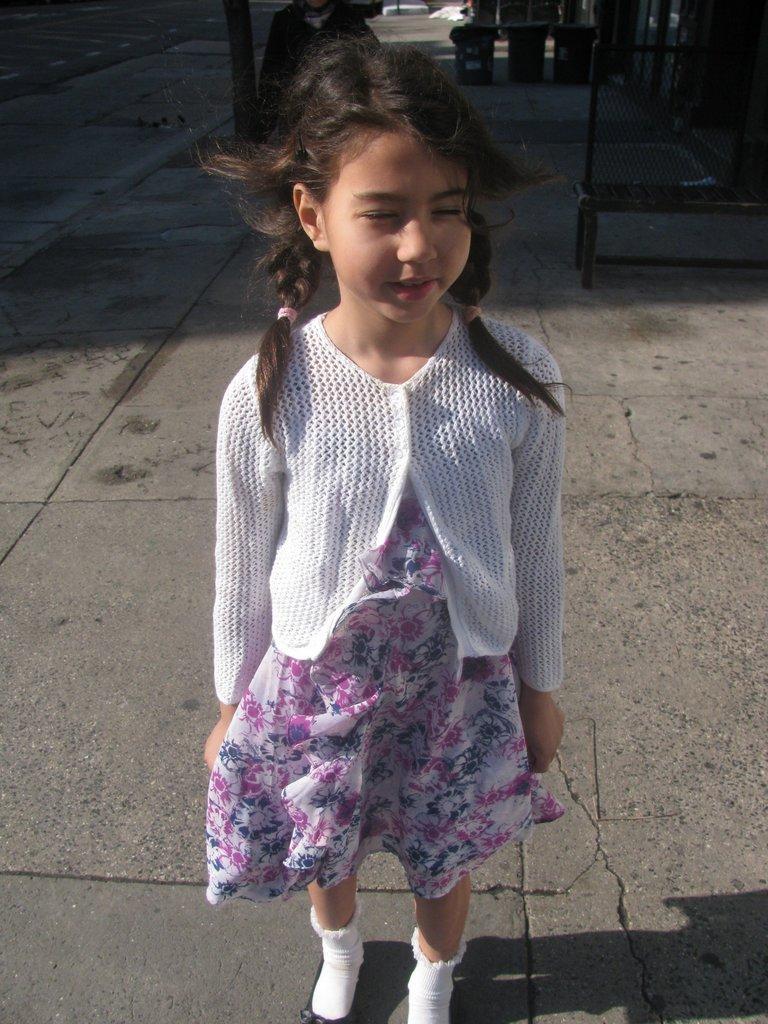Could you give a brief overview of what you see in this image? Here I can see a girl wearing a frock, white color jacket and standing on the ground. In the background there is another person. In the top right I can see three dustbins and a bench on the ground and also there is a wall. 